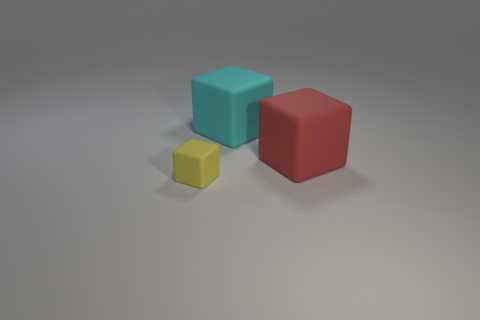Are there any cyan rubber blocks on the right side of the yellow rubber block?
Provide a succinct answer. Yes. What number of cylinders are big blue metallic objects or big objects?
Your response must be concise. 0. Does the small rubber thing have the same shape as the cyan object?
Keep it short and to the point. Yes. There is a cube that is in front of the red matte cube; what is its size?
Provide a succinct answer. Small. Are there any cylinders that have the same color as the tiny object?
Your answer should be compact. No. Do the red matte object on the right side of the cyan rubber cube and the cyan matte cube have the same size?
Keep it short and to the point. Yes. What is the color of the tiny rubber object?
Your response must be concise. Yellow. There is a cube in front of the big thing on the right side of the cyan thing; what is its color?
Make the answer very short. Yellow. Is there a big cyan cube that has the same material as the cyan thing?
Your answer should be compact. No. The large thing right of the big rubber thing behind the big red object is made of what material?
Your answer should be very brief. Rubber. 